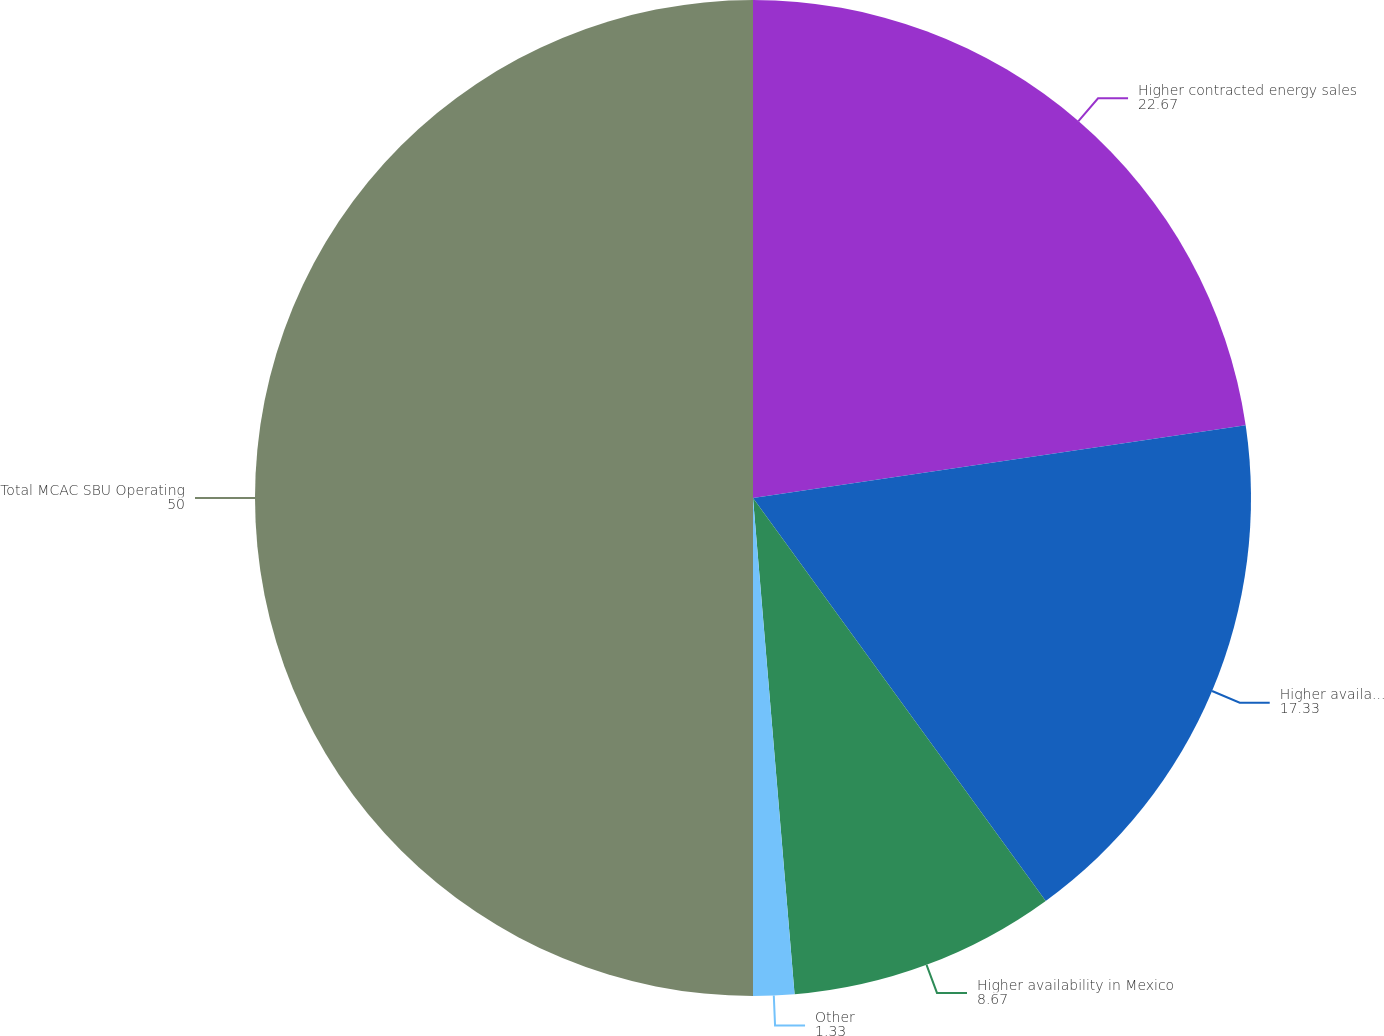Convert chart. <chart><loc_0><loc_0><loc_500><loc_500><pie_chart><fcel>Higher contracted energy sales<fcel>Higher availability driven by<fcel>Higher availability in Mexico<fcel>Other<fcel>Total MCAC SBU Operating<nl><fcel>22.67%<fcel>17.33%<fcel>8.67%<fcel>1.33%<fcel>50.0%<nl></chart> 